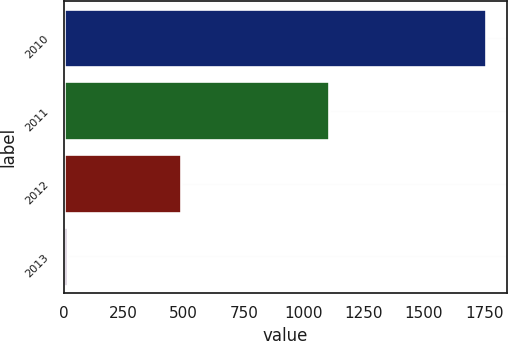Convert chart. <chart><loc_0><loc_0><loc_500><loc_500><bar_chart><fcel>2010<fcel>2011<fcel>2012<fcel>2013<nl><fcel>1759<fcel>1104<fcel>487<fcel>13<nl></chart> 